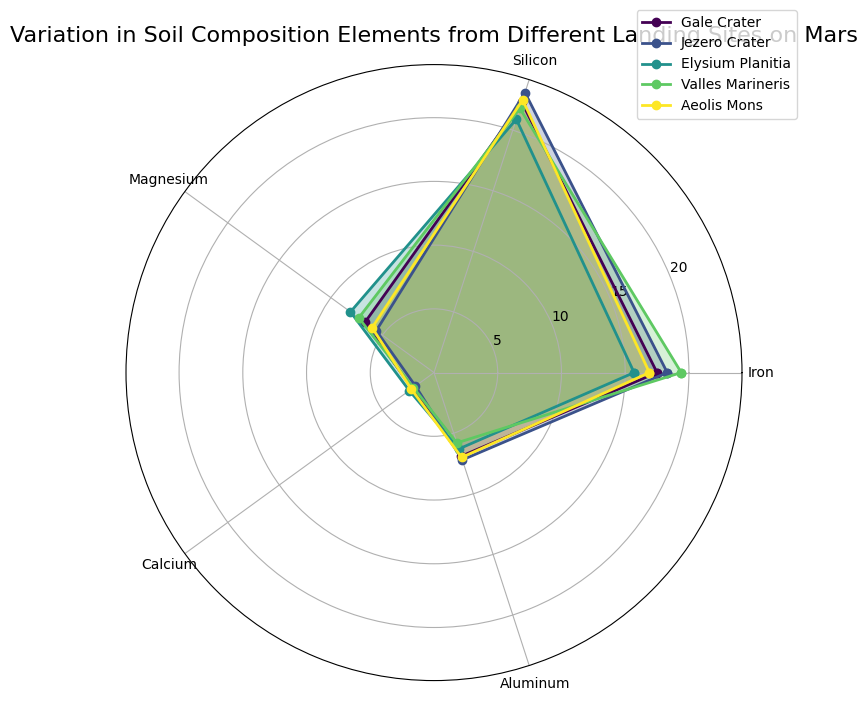Which landing site has the highest percentage of Iron? When examining the plot, the line representing Valles Marineris extends farthest in the Iron section, indicating it has the highest percentage of Iron.
Answer: Valles Marineris Which two elements have the smallest percentage differences between Gale Crater and Aeolis Mons? Comparing the distances of the lines' radii for each element, the Magnesium and Calcium lines between Gale Crater and Aeolis Mons are closest, indicating the smallest percentage differences.
Answer: Magnesium and Calcium Which landing site shows the highest percentage for Silicon? The line corresponding to Jezero Crater extends the farthest in the Silicon segment of the chart, making it the landing site with the highest percentage for Silicon.
Answer: Jezero Crater Considering only Iron and Aluminum, which landing site shows a greater combined percentage, Gale Crater or Elysium Planitia? Summing up the percentages for Iron and Aluminum, Gale Crater has 17.5 (Iron) + 6.9 (Aluminum) = 24.4, whereas Elysium Planitia has 15.7 (Iron) + 6.3 (Aluminum) = 22.0, indicating Gale Crater has a greater combined percentage for these two elements.
Answer: Gale Crater Which landing site has the highest average percentage of all elements? Calculating the average for each landing site by summing the percentages of all elements and dividing by the number of elements: Gale Crater: (17.5 + 22.3 + 6.7 + 2.1 + 6.9) / 5 = 11.1; Jezero Crater: (18.3 + 23.1 + 5.6 + 1.8 + 7.2) / 5 = 11.2; Elysium Planitia: (15.7 + 20.9 + 8.1 + 2.4 + 6.3) / 5 = 10.68; Valles Marineris: (19.4 + 21.8 + 7.3 + 2.0 + 5.8) / 5 = 11.26; Aeolis Mons: (16.9 + 22.5 + 6.0 + 2.2 + 7.0) / 5 = 10.92. Valles Marineris has the highest average.
Answer: Valles Marineris Is there an element where Jezero Crater and Aeolis Mons have the same percentage? By visually inspecting the plot, none of the sections (representing elements) overlap perfectly between Jezero Crater and Aeolis Mons, indicating there is no element where they have the same percentage.
Answer: No For Gale Crater, which element has the smallest percentage and how can you identify it? By comparing all elements' segments, Gale Crater's Calcium section extends the least, indicating it has the smallest percentage of Calcium at 2.1%.
Answer: Calcium at 2.1% How does the percentage of Magnesium in Gale Crater compare to the same element in Elysium Planitia? Observing the lengths of the respective segments for Magnesium, Elysium Planitia's segment is longer than Gale Crater's, indicating Elysium Planitia has a higher percentage of Magnesium.
Answer: Elysium Planitia is higher 